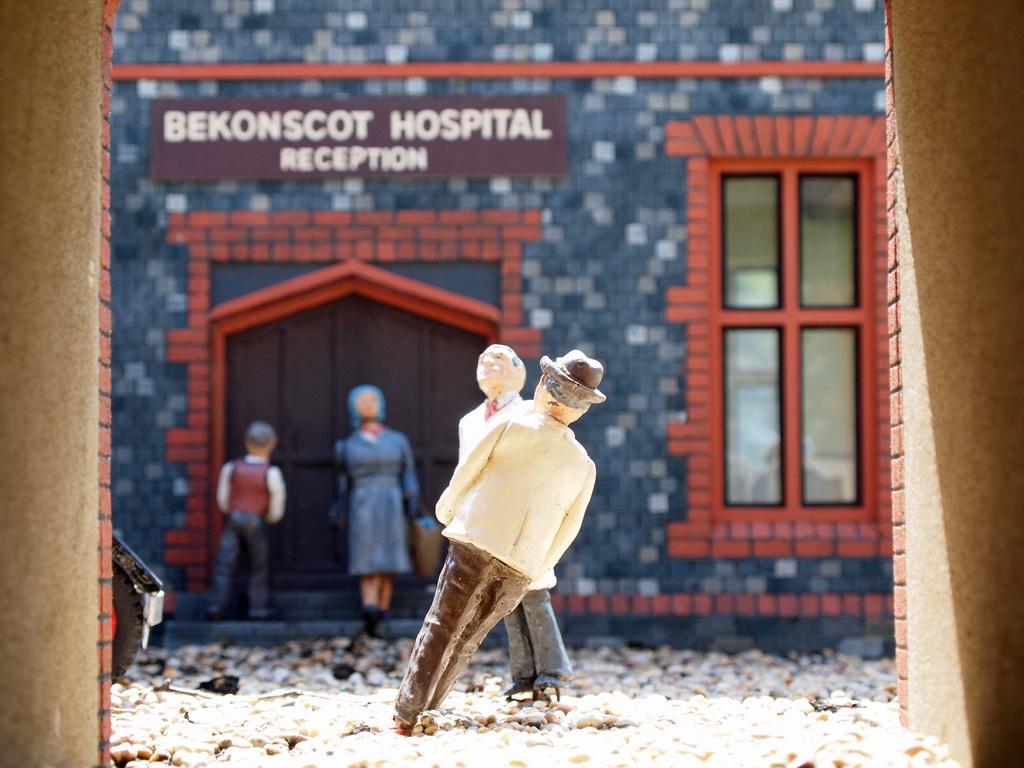In one or two sentences, can you explain what this image depicts? In the middle of the image there are two statues. On the left and right sides of the image there are walls. On the ground there are stones. In the background there is a building with walls, windows and also there is a door. In front of the door there are two statues. And there is a name board on the wall. 